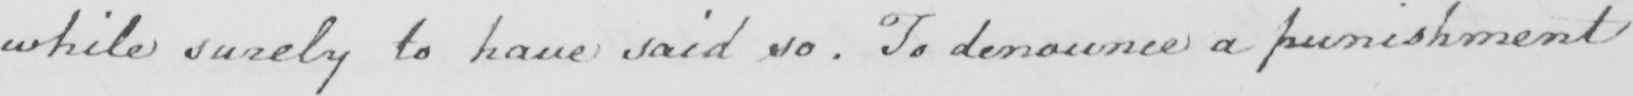Can you read and transcribe this handwriting? while surely to have said so . To denounce a punishment 